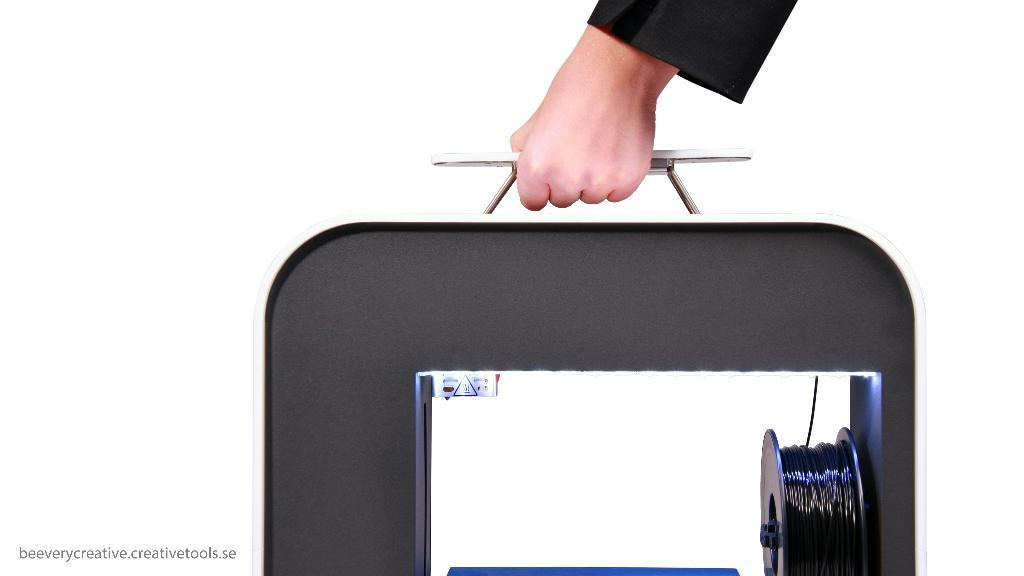What is the main subject of the image? There is a person in the image. What is the person holding in the image? The person is holding a stand of something. Can you describe the stand in more detail? There are wires on the stand. How many grains of rice can be seen on the person's clothing in the image? There is no rice or grains visible on the person's clothing in the image. Is there a baby present in the image? No, there is no baby present in the image. 